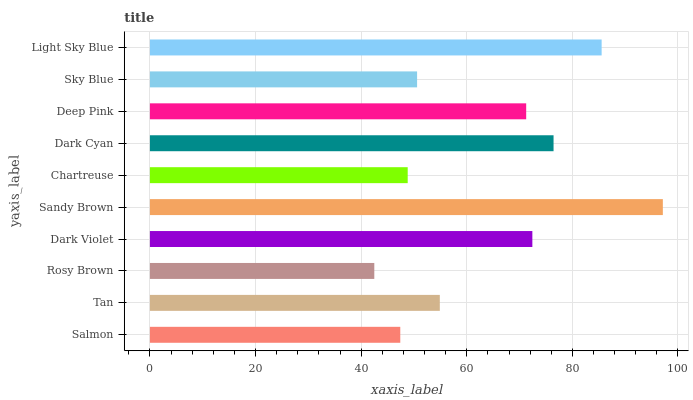Is Rosy Brown the minimum?
Answer yes or no. Yes. Is Sandy Brown the maximum?
Answer yes or no. Yes. Is Tan the minimum?
Answer yes or no. No. Is Tan the maximum?
Answer yes or no. No. Is Tan greater than Salmon?
Answer yes or no. Yes. Is Salmon less than Tan?
Answer yes or no. Yes. Is Salmon greater than Tan?
Answer yes or no. No. Is Tan less than Salmon?
Answer yes or no. No. Is Deep Pink the high median?
Answer yes or no. Yes. Is Tan the low median?
Answer yes or no. Yes. Is Sandy Brown the high median?
Answer yes or no. No. Is Dark Violet the low median?
Answer yes or no. No. 